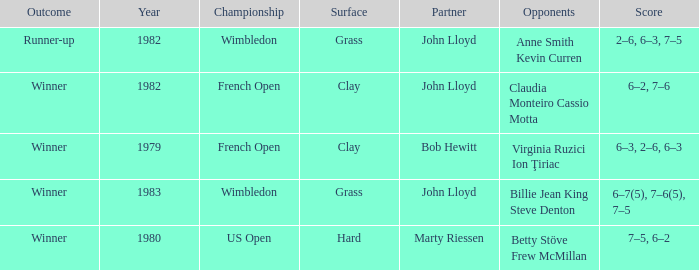What was the surface for events held in 1983? Grass. 